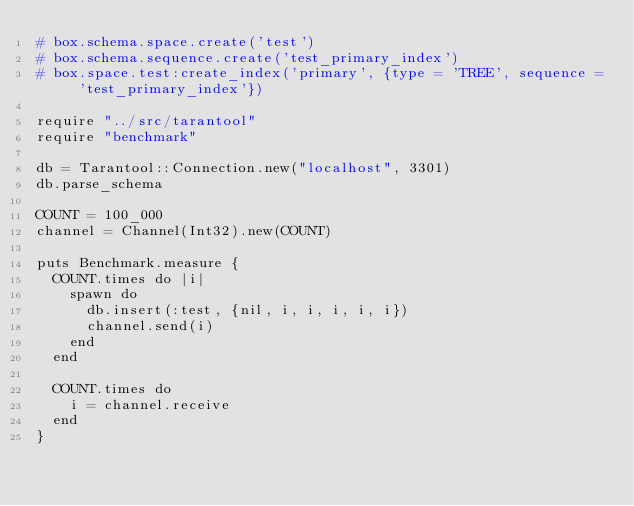Convert code to text. <code><loc_0><loc_0><loc_500><loc_500><_Crystal_># box.schema.space.create('test')
# box.schema.sequence.create('test_primary_index')
# box.space.test:create_index('primary', {type = 'TREE', sequence = 'test_primary_index'})

require "../src/tarantool"
require "benchmark"

db = Tarantool::Connection.new("localhost", 3301)
db.parse_schema

COUNT = 100_000
channel = Channel(Int32).new(COUNT)

puts Benchmark.measure {
  COUNT.times do |i|
    spawn do
      db.insert(:test, {nil, i, i, i, i, i})
      channel.send(i)
    end
  end

  COUNT.times do
    i = channel.receive
  end
}
</code> 